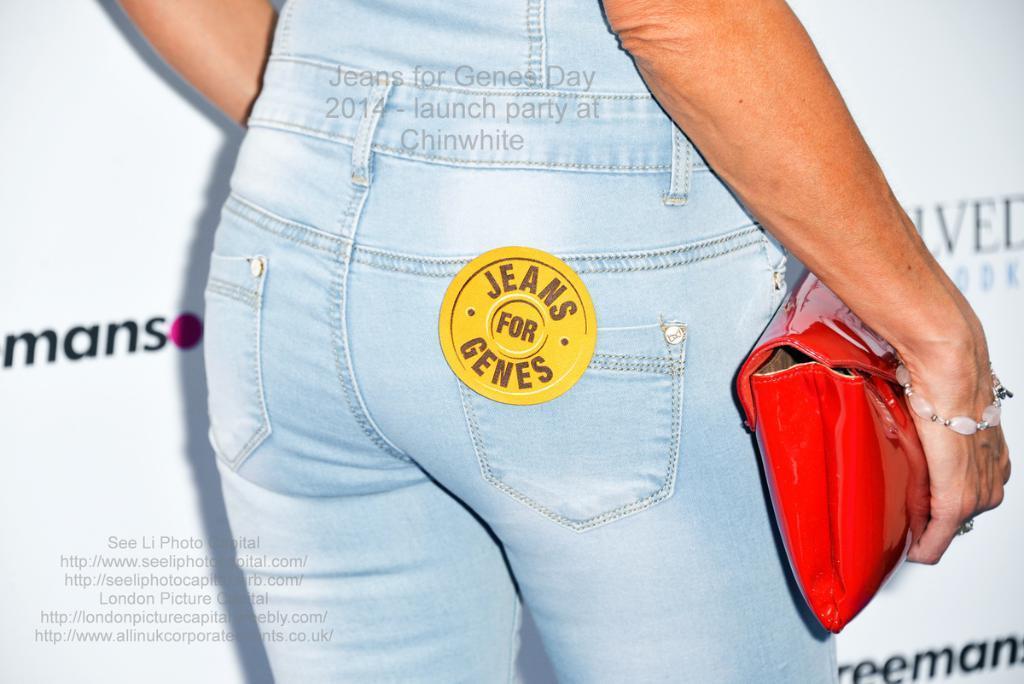In one or two sentences, can you explain what this image depicts? In this picture I can see a woman who is wearing jeans and holding a red color purse. In front of her I can see the banner. In the bottom left and at the top I can see the watermarks. 